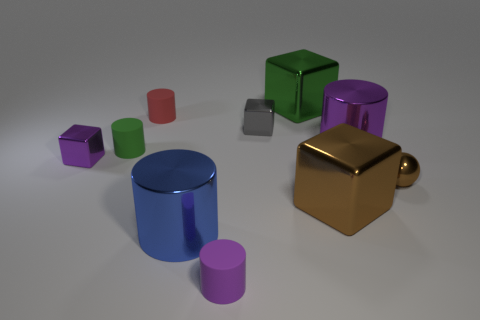What textures are visible on the objects in the image? The objects in the image display a variety of textures. The large blue cylinder, the brown cube with a rounded edge (or a teapot-like object), and the green cube reflect light and have a smooth metal texture. In contrast, the remaining objects seem to have a matte surface suggesting a non-metallic, possibly plastic or painted wood texture. 